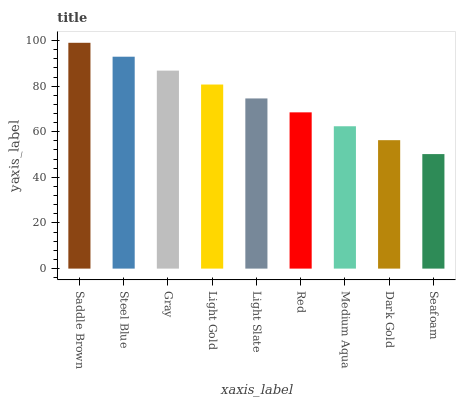Is Seafoam the minimum?
Answer yes or no. Yes. Is Saddle Brown the maximum?
Answer yes or no. Yes. Is Steel Blue the minimum?
Answer yes or no. No. Is Steel Blue the maximum?
Answer yes or no. No. Is Saddle Brown greater than Steel Blue?
Answer yes or no. Yes. Is Steel Blue less than Saddle Brown?
Answer yes or no. Yes. Is Steel Blue greater than Saddle Brown?
Answer yes or no. No. Is Saddle Brown less than Steel Blue?
Answer yes or no. No. Is Light Slate the high median?
Answer yes or no. Yes. Is Light Slate the low median?
Answer yes or no. Yes. Is Light Gold the high median?
Answer yes or no. No. Is Seafoam the low median?
Answer yes or no. No. 